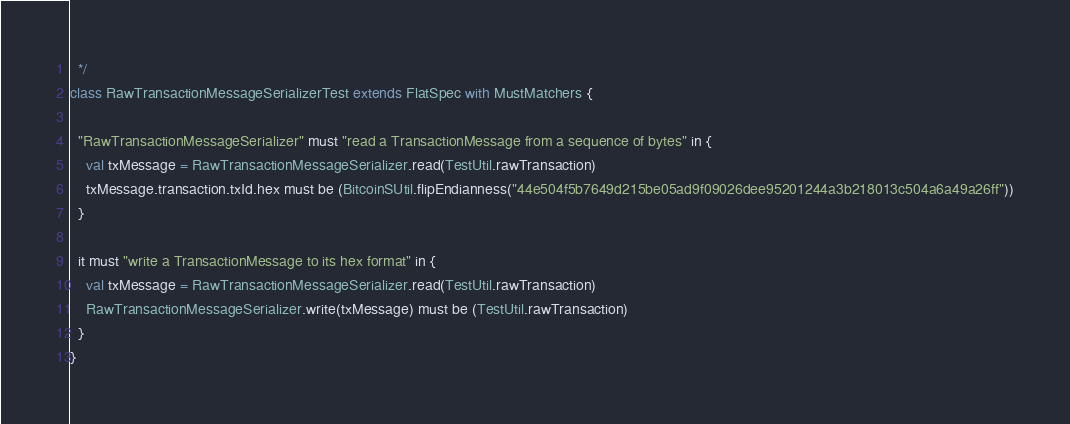<code> <loc_0><loc_0><loc_500><loc_500><_Scala_>  */
class RawTransactionMessageSerializerTest extends FlatSpec with MustMatchers {

  "RawTransactionMessageSerializer" must "read a TransactionMessage from a sequence of bytes" in {
    val txMessage = RawTransactionMessageSerializer.read(TestUtil.rawTransaction)
    txMessage.transaction.txId.hex must be (BitcoinSUtil.flipEndianness("44e504f5b7649d215be05ad9f09026dee95201244a3b218013c504a6a49a26ff"))
  }

  it must "write a TransactionMessage to its hex format" in {
    val txMessage = RawTransactionMessageSerializer.read(TestUtil.rawTransaction)
    RawTransactionMessageSerializer.write(txMessage) must be (TestUtil.rawTransaction)
  }
}
</code> 